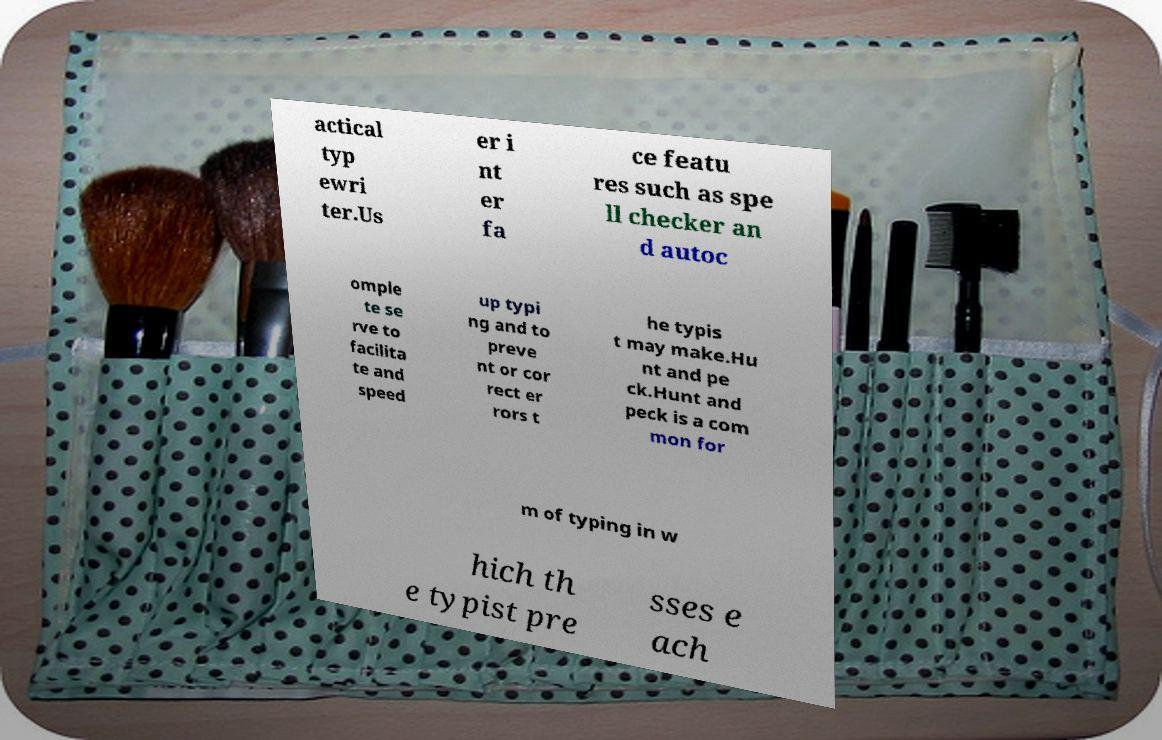Can you accurately transcribe the text from the provided image for me? actical typ ewri ter.Us er i nt er fa ce featu res such as spe ll checker an d autoc omple te se rve to facilita te and speed up typi ng and to preve nt or cor rect er rors t he typis t may make.Hu nt and pe ck.Hunt and peck is a com mon for m of typing in w hich th e typist pre sses e ach 